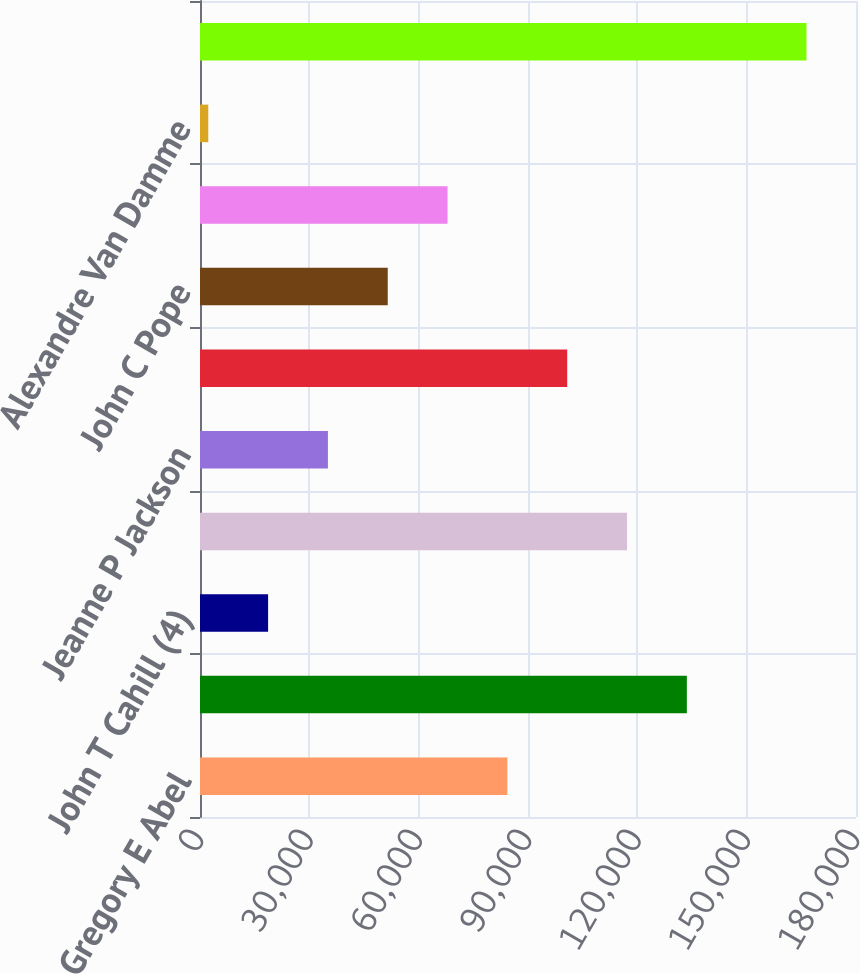Convert chart. <chart><loc_0><loc_0><loc_500><loc_500><bar_chart><fcel>Gregory E Abel<fcel>Alexandre Behring<fcel>John T Cahill (4)<fcel>Tracy Britt Cool<fcel>Jeanne P Jackson<fcel>Jorge Paulo Lemann<fcel>John C Pope<fcel>Marcel Hermann Telles<fcel>Alexandre Van Damme<fcel>All directors and executive<nl><fcel>84343.5<fcel>133588<fcel>18683.9<fcel>117173<fcel>35098.8<fcel>100758<fcel>51513.7<fcel>67928.6<fcel>2269<fcel>166418<nl></chart> 